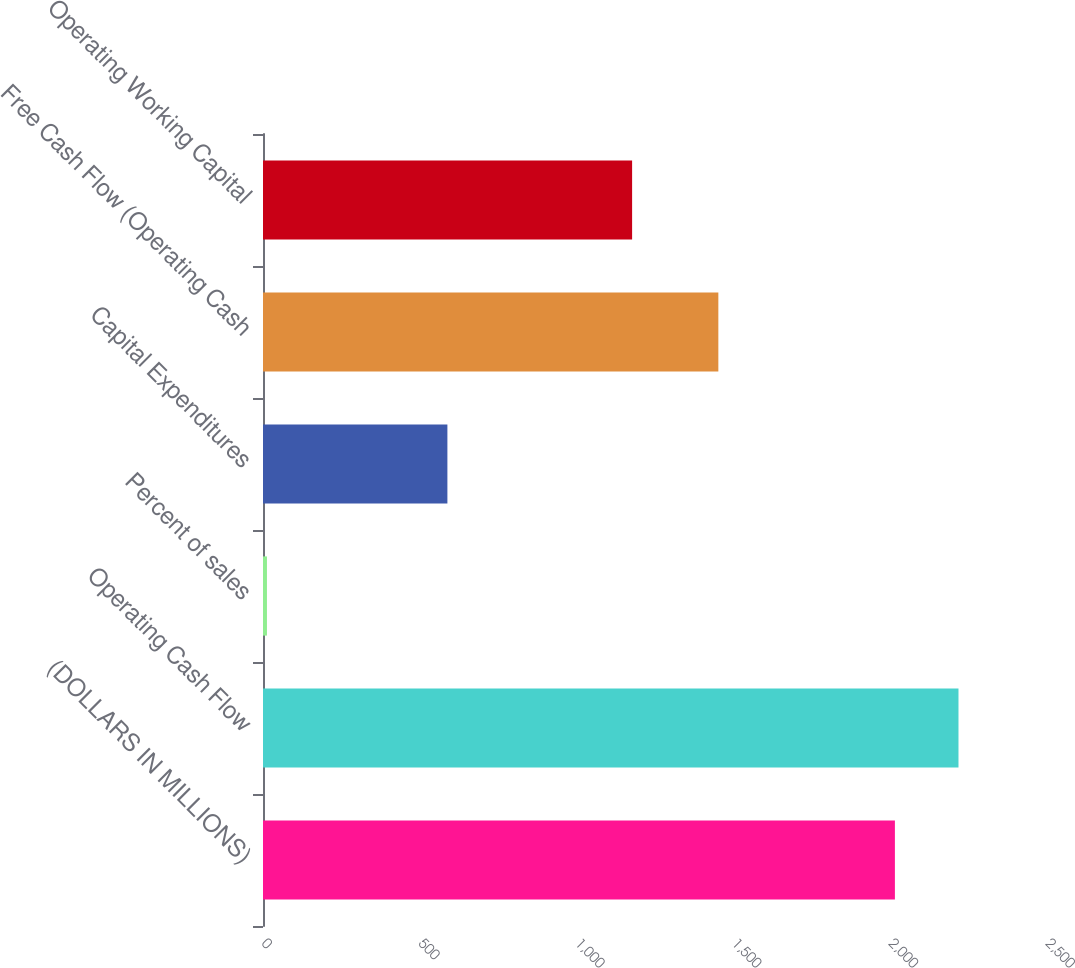<chart> <loc_0><loc_0><loc_500><loc_500><bar_chart><fcel>(DOLLARS IN MILLIONS)<fcel>Operating Cash Flow<fcel>Percent of sales<fcel>Capital Expenditures<fcel>Free Cash Flow (Operating Cash<fcel>Operating Working Capital<nl><fcel>2015<fcel>2217.74<fcel>12.6<fcel>588<fcel>1452<fcel>1177<nl></chart> 